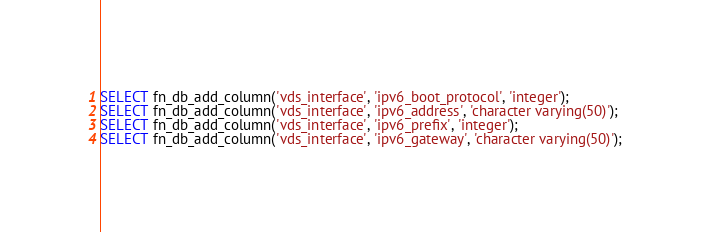<code> <loc_0><loc_0><loc_500><loc_500><_SQL_>SELECT fn_db_add_column('vds_interface', 'ipv6_boot_protocol', 'integer');
SELECT fn_db_add_column('vds_interface', 'ipv6_address', 'character varying(50)');
SELECT fn_db_add_column('vds_interface', 'ipv6_prefix', 'integer');
SELECT fn_db_add_column('vds_interface', 'ipv6_gateway', 'character varying(50)');
</code> 